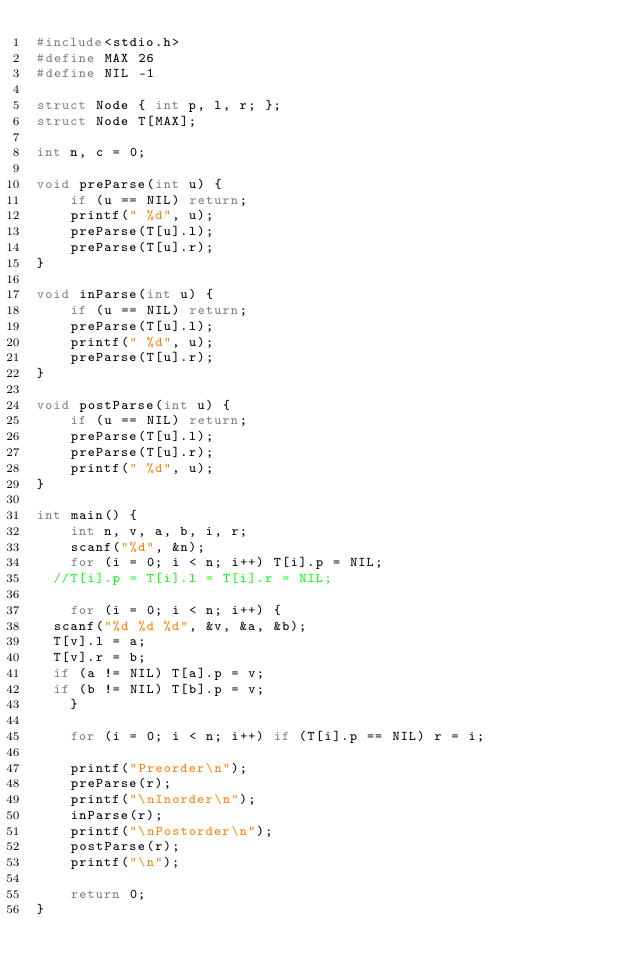Convert code to text. <code><loc_0><loc_0><loc_500><loc_500><_C_>#include<stdio.h>
#define MAX 26
#define NIL -1

struct Node { int p, l, r; };
struct Node T[MAX];

int n, c = 0;

void preParse(int u) {
    if (u == NIL) return;
    printf(" %d", u);
    preParse(T[u].l);
    preParse(T[u].r);
}

void inParse(int u) {
    if (u == NIL) return;
    preParse(T[u].l);
    printf(" %d", u);
    preParse(T[u].r);
}

void postParse(int u) {
    if (u == NIL) return;
    preParse(T[u].l);
    preParse(T[u].r);
    printf(" %d", u);
}

int main() {
    int n, v, a, b, i, r;
    scanf("%d", &n);
    for (i = 0; i < n; i++) T[i].p = NIL;
	//T[i].p = T[i].l = T[i].r = NIL;
    
    for (i = 0; i < n; i++) {
	scanf("%d %d %d", &v, &a, &b);
	T[v].l = a;
	T[v].r = b;
	if (a != NIL) T[a].p = v;
	if (b != NIL) T[b].p = v;
    }

    for (i = 0; i < n; i++) if (T[i].p == NIL) r = i;
    
    printf("Preorder\n");
    preParse(r);
    printf("\nInorder\n");
    inParse(r);
    printf("\nPostorder\n");
    postParse(r);
    printf("\n");

    return 0;
}</code> 